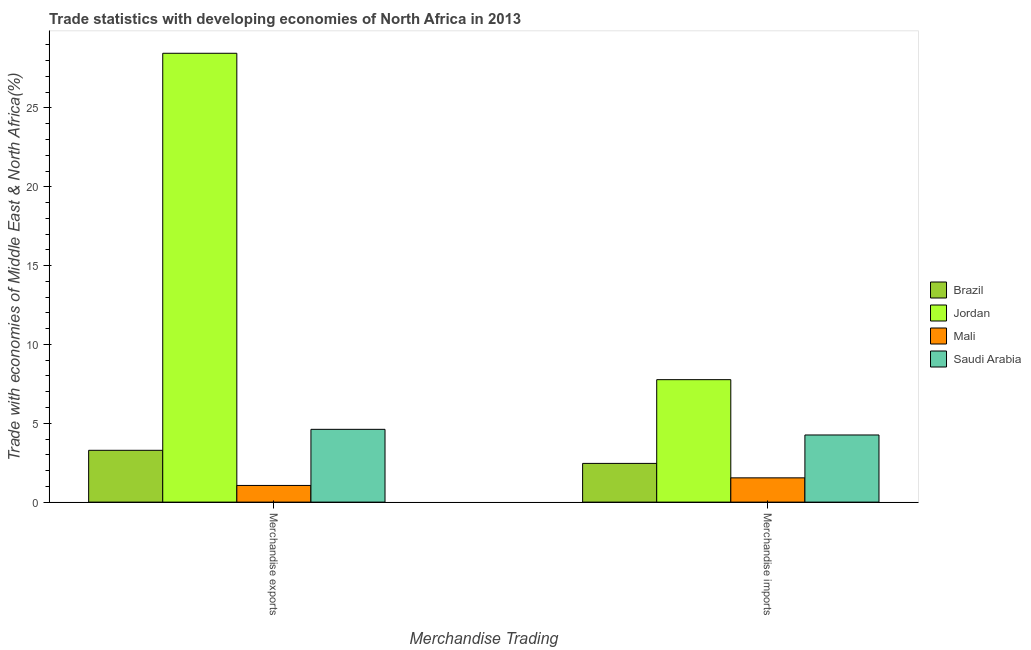How many different coloured bars are there?
Give a very brief answer. 4. How many groups of bars are there?
Keep it short and to the point. 2. Are the number of bars per tick equal to the number of legend labels?
Make the answer very short. Yes. What is the merchandise imports in Saudi Arabia?
Make the answer very short. 4.26. Across all countries, what is the maximum merchandise imports?
Give a very brief answer. 7.77. Across all countries, what is the minimum merchandise exports?
Offer a very short reply. 1.06. In which country was the merchandise exports maximum?
Your answer should be very brief. Jordan. In which country was the merchandise imports minimum?
Your answer should be compact. Mali. What is the total merchandise imports in the graph?
Offer a terse response. 16.02. What is the difference between the merchandise exports in Brazil and that in Jordan?
Offer a terse response. -25.18. What is the difference between the merchandise exports in Brazil and the merchandise imports in Jordan?
Keep it short and to the point. -4.48. What is the average merchandise exports per country?
Offer a very short reply. 9.36. What is the difference between the merchandise exports and merchandise imports in Mali?
Your response must be concise. -0.48. What is the ratio of the merchandise imports in Jordan to that in Brazil?
Offer a terse response. 3.16. Is the merchandise exports in Saudi Arabia less than that in Jordan?
Keep it short and to the point. Yes. What does the 2nd bar from the right in Merchandise imports represents?
Provide a succinct answer. Mali. How many bars are there?
Offer a terse response. 8. Are all the bars in the graph horizontal?
Provide a succinct answer. No. What is the difference between two consecutive major ticks on the Y-axis?
Offer a terse response. 5. Does the graph contain any zero values?
Provide a succinct answer. No. Does the graph contain grids?
Ensure brevity in your answer.  No. Where does the legend appear in the graph?
Give a very brief answer. Center right. How many legend labels are there?
Ensure brevity in your answer.  4. What is the title of the graph?
Provide a short and direct response. Trade statistics with developing economies of North Africa in 2013. What is the label or title of the X-axis?
Your answer should be very brief. Merchandise Trading. What is the label or title of the Y-axis?
Give a very brief answer. Trade with economies of Middle East & North Africa(%). What is the Trade with economies of Middle East & North Africa(%) in Brazil in Merchandise exports?
Provide a succinct answer. 3.29. What is the Trade with economies of Middle East & North Africa(%) of Jordan in Merchandise exports?
Give a very brief answer. 28.47. What is the Trade with economies of Middle East & North Africa(%) of Mali in Merchandise exports?
Offer a terse response. 1.06. What is the Trade with economies of Middle East & North Africa(%) of Saudi Arabia in Merchandise exports?
Your answer should be compact. 4.62. What is the Trade with economies of Middle East & North Africa(%) in Brazil in Merchandise imports?
Make the answer very short. 2.46. What is the Trade with economies of Middle East & North Africa(%) in Jordan in Merchandise imports?
Provide a succinct answer. 7.77. What is the Trade with economies of Middle East & North Africa(%) in Mali in Merchandise imports?
Your response must be concise. 1.54. What is the Trade with economies of Middle East & North Africa(%) of Saudi Arabia in Merchandise imports?
Your response must be concise. 4.26. Across all Merchandise Trading, what is the maximum Trade with economies of Middle East & North Africa(%) of Brazil?
Make the answer very short. 3.29. Across all Merchandise Trading, what is the maximum Trade with economies of Middle East & North Africa(%) in Jordan?
Your answer should be very brief. 28.47. Across all Merchandise Trading, what is the maximum Trade with economies of Middle East & North Africa(%) in Mali?
Your answer should be very brief. 1.54. Across all Merchandise Trading, what is the maximum Trade with economies of Middle East & North Africa(%) of Saudi Arabia?
Your response must be concise. 4.62. Across all Merchandise Trading, what is the minimum Trade with economies of Middle East & North Africa(%) in Brazil?
Ensure brevity in your answer.  2.46. Across all Merchandise Trading, what is the minimum Trade with economies of Middle East & North Africa(%) in Jordan?
Ensure brevity in your answer.  7.77. Across all Merchandise Trading, what is the minimum Trade with economies of Middle East & North Africa(%) in Mali?
Provide a succinct answer. 1.06. Across all Merchandise Trading, what is the minimum Trade with economies of Middle East & North Africa(%) of Saudi Arabia?
Your response must be concise. 4.26. What is the total Trade with economies of Middle East & North Africa(%) of Brazil in the graph?
Provide a succinct answer. 5.74. What is the total Trade with economies of Middle East & North Africa(%) of Jordan in the graph?
Offer a terse response. 36.23. What is the total Trade with economies of Middle East & North Africa(%) in Mali in the graph?
Offer a terse response. 2.6. What is the total Trade with economies of Middle East & North Africa(%) in Saudi Arabia in the graph?
Provide a short and direct response. 8.87. What is the difference between the Trade with economies of Middle East & North Africa(%) of Brazil in Merchandise exports and that in Merchandise imports?
Ensure brevity in your answer.  0.83. What is the difference between the Trade with economies of Middle East & North Africa(%) in Jordan in Merchandise exports and that in Merchandise imports?
Offer a very short reply. 20.7. What is the difference between the Trade with economies of Middle East & North Africa(%) in Mali in Merchandise exports and that in Merchandise imports?
Give a very brief answer. -0.48. What is the difference between the Trade with economies of Middle East & North Africa(%) of Saudi Arabia in Merchandise exports and that in Merchandise imports?
Keep it short and to the point. 0.36. What is the difference between the Trade with economies of Middle East & North Africa(%) of Brazil in Merchandise exports and the Trade with economies of Middle East & North Africa(%) of Jordan in Merchandise imports?
Make the answer very short. -4.48. What is the difference between the Trade with economies of Middle East & North Africa(%) in Brazil in Merchandise exports and the Trade with economies of Middle East & North Africa(%) in Mali in Merchandise imports?
Ensure brevity in your answer.  1.75. What is the difference between the Trade with economies of Middle East & North Africa(%) in Brazil in Merchandise exports and the Trade with economies of Middle East & North Africa(%) in Saudi Arabia in Merchandise imports?
Offer a very short reply. -0.97. What is the difference between the Trade with economies of Middle East & North Africa(%) of Jordan in Merchandise exports and the Trade with economies of Middle East & North Africa(%) of Mali in Merchandise imports?
Keep it short and to the point. 26.93. What is the difference between the Trade with economies of Middle East & North Africa(%) in Jordan in Merchandise exports and the Trade with economies of Middle East & North Africa(%) in Saudi Arabia in Merchandise imports?
Provide a short and direct response. 24.21. What is the difference between the Trade with economies of Middle East & North Africa(%) in Mali in Merchandise exports and the Trade with economies of Middle East & North Africa(%) in Saudi Arabia in Merchandise imports?
Keep it short and to the point. -3.2. What is the average Trade with economies of Middle East & North Africa(%) of Brazil per Merchandise Trading?
Provide a succinct answer. 2.87. What is the average Trade with economies of Middle East & North Africa(%) of Jordan per Merchandise Trading?
Offer a very short reply. 18.12. What is the average Trade with economies of Middle East & North Africa(%) of Mali per Merchandise Trading?
Your answer should be very brief. 1.3. What is the average Trade with economies of Middle East & North Africa(%) of Saudi Arabia per Merchandise Trading?
Offer a very short reply. 4.44. What is the difference between the Trade with economies of Middle East & North Africa(%) in Brazil and Trade with economies of Middle East & North Africa(%) in Jordan in Merchandise exports?
Your answer should be compact. -25.18. What is the difference between the Trade with economies of Middle East & North Africa(%) in Brazil and Trade with economies of Middle East & North Africa(%) in Mali in Merchandise exports?
Ensure brevity in your answer.  2.23. What is the difference between the Trade with economies of Middle East & North Africa(%) of Brazil and Trade with economies of Middle East & North Africa(%) of Saudi Arabia in Merchandise exports?
Give a very brief answer. -1.33. What is the difference between the Trade with economies of Middle East & North Africa(%) in Jordan and Trade with economies of Middle East & North Africa(%) in Mali in Merchandise exports?
Offer a terse response. 27.41. What is the difference between the Trade with economies of Middle East & North Africa(%) of Jordan and Trade with economies of Middle East & North Africa(%) of Saudi Arabia in Merchandise exports?
Make the answer very short. 23.85. What is the difference between the Trade with economies of Middle East & North Africa(%) of Mali and Trade with economies of Middle East & North Africa(%) of Saudi Arabia in Merchandise exports?
Your answer should be very brief. -3.56. What is the difference between the Trade with economies of Middle East & North Africa(%) in Brazil and Trade with economies of Middle East & North Africa(%) in Jordan in Merchandise imports?
Give a very brief answer. -5.31. What is the difference between the Trade with economies of Middle East & North Africa(%) of Brazil and Trade with economies of Middle East & North Africa(%) of Mali in Merchandise imports?
Your response must be concise. 0.92. What is the difference between the Trade with economies of Middle East & North Africa(%) in Brazil and Trade with economies of Middle East & North Africa(%) in Saudi Arabia in Merchandise imports?
Offer a terse response. -1.8. What is the difference between the Trade with economies of Middle East & North Africa(%) of Jordan and Trade with economies of Middle East & North Africa(%) of Mali in Merchandise imports?
Keep it short and to the point. 6.23. What is the difference between the Trade with economies of Middle East & North Africa(%) of Jordan and Trade with economies of Middle East & North Africa(%) of Saudi Arabia in Merchandise imports?
Ensure brevity in your answer.  3.51. What is the difference between the Trade with economies of Middle East & North Africa(%) in Mali and Trade with economies of Middle East & North Africa(%) in Saudi Arabia in Merchandise imports?
Your answer should be compact. -2.72. What is the ratio of the Trade with economies of Middle East & North Africa(%) in Brazil in Merchandise exports to that in Merchandise imports?
Provide a succinct answer. 1.34. What is the ratio of the Trade with economies of Middle East & North Africa(%) in Jordan in Merchandise exports to that in Merchandise imports?
Ensure brevity in your answer.  3.67. What is the ratio of the Trade with economies of Middle East & North Africa(%) of Mali in Merchandise exports to that in Merchandise imports?
Ensure brevity in your answer.  0.69. What is the ratio of the Trade with economies of Middle East & North Africa(%) of Saudi Arabia in Merchandise exports to that in Merchandise imports?
Your response must be concise. 1.08. What is the difference between the highest and the second highest Trade with economies of Middle East & North Africa(%) in Brazil?
Provide a succinct answer. 0.83. What is the difference between the highest and the second highest Trade with economies of Middle East & North Africa(%) in Jordan?
Ensure brevity in your answer.  20.7. What is the difference between the highest and the second highest Trade with economies of Middle East & North Africa(%) in Mali?
Keep it short and to the point. 0.48. What is the difference between the highest and the second highest Trade with economies of Middle East & North Africa(%) of Saudi Arabia?
Provide a short and direct response. 0.36. What is the difference between the highest and the lowest Trade with economies of Middle East & North Africa(%) in Brazil?
Your answer should be compact. 0.83. What is the difference between the highest and the lowest Trade with economies of Middle East & North Africa(%) in Jordan?
Provide a short and direct response. 20.7. What is the difference between the highest and the lowest Trade with economies of Middle East & North Africa(%) of Mali?
Offer a very short reply. 0.48. What is the difference between the highest and the lowest Trade with economies of Middle East & North Africa(%) in Saudi Arabia?
Give a very brief answer. 0.36. 